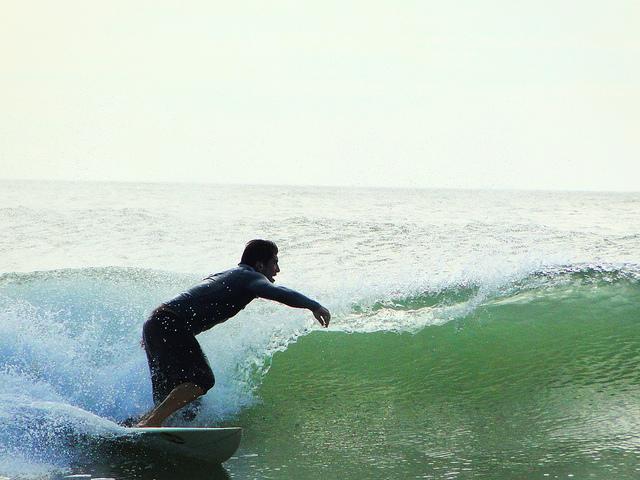What is the man on?
Write a very short answer. Surfboard. What color is the wave?
Be succinct. Green. What's the man doing?
Write a very short answer. Surfing. Does this look safe with a wall next to you?
Keep it brief. No. What color is the water?
Quick response, please. Green. 